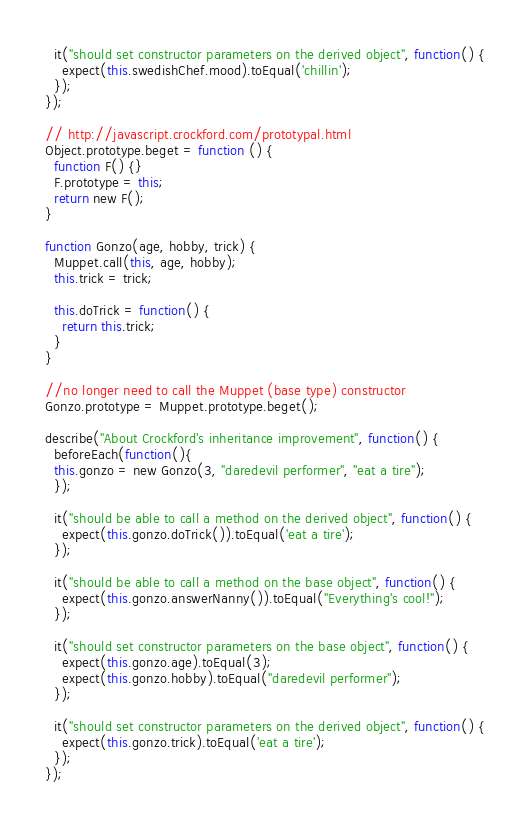<code> <loc_0><loc_0><loc_500><loc_500><_JavaScript_>  it("should set constructor parameters on the derived object", function() {
    expect(this.swedishChef.mood).toEqual('chillin');
  });
});

// http://javascript.crockford.com/prototypal.html
Object.prototype.beget = function () {
  function F() {}
  F.prototype = this;
  return new F();
}

function Gonzo(age, hobby, trick) {
  Muppet.call(this, age, hobby);
  this.trick = trick;

  this.doTrick = function() {
    return this.trick;
  }
}

//no longer need to call the Muppet (base type) constructor
Gonzo.prototype = Muppet.prototype.beget();

describe("About Crockford's inheritance improvement", function() {
  beforeEach(function(){
  this.gonzo = new Gonzo(3, "daredevil performer", "eat a tire");
  });

  it("should be able to call a method on the derived object", function() {
    expect(this.gonzo.doTrick()).toEqual('eat a tire');
  });

  it("should be able to call a method on the base object", function() {
    expect(this.gonzo.answerNanny()).toEqual("Everything's cool!");
  });

  it("should set constructor parameters on the base object", function() {
    expect(this.gonzo.age).toEqual(3);
    expect(this.gonzo.hobby).toEqual("daredevil performer");
  });

  it("should set constructor parameters on the derived object", function() {
    expect(this.gonzo.trick).toEqual('eat a tire');
  });
});
</code> 